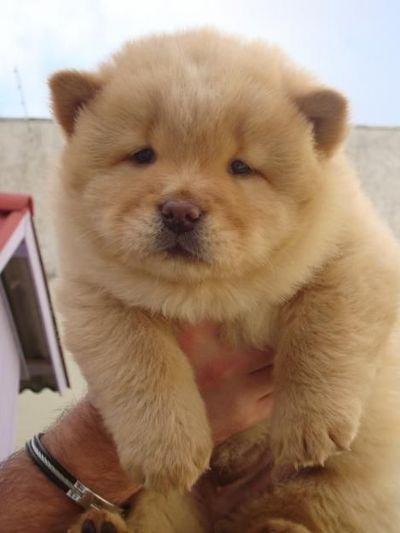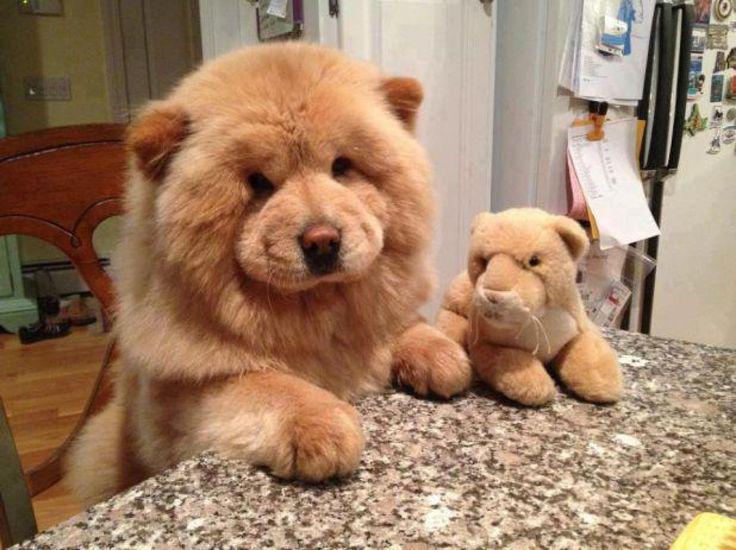The first image is the image on the left, the second image is the image on the right. Examine the images to the left and right. Is the description "The left and right image contains the same number of dogs with at least one laying down." accurate? Answer yes or no. No. The first image is the image on the left, the second image is the image on the right. Considering the images on both sides, is "The combined images include two chows and one other animal figure, all are the same color, and at least two have their paws forward." valid? Answer yes or no. Yes. 